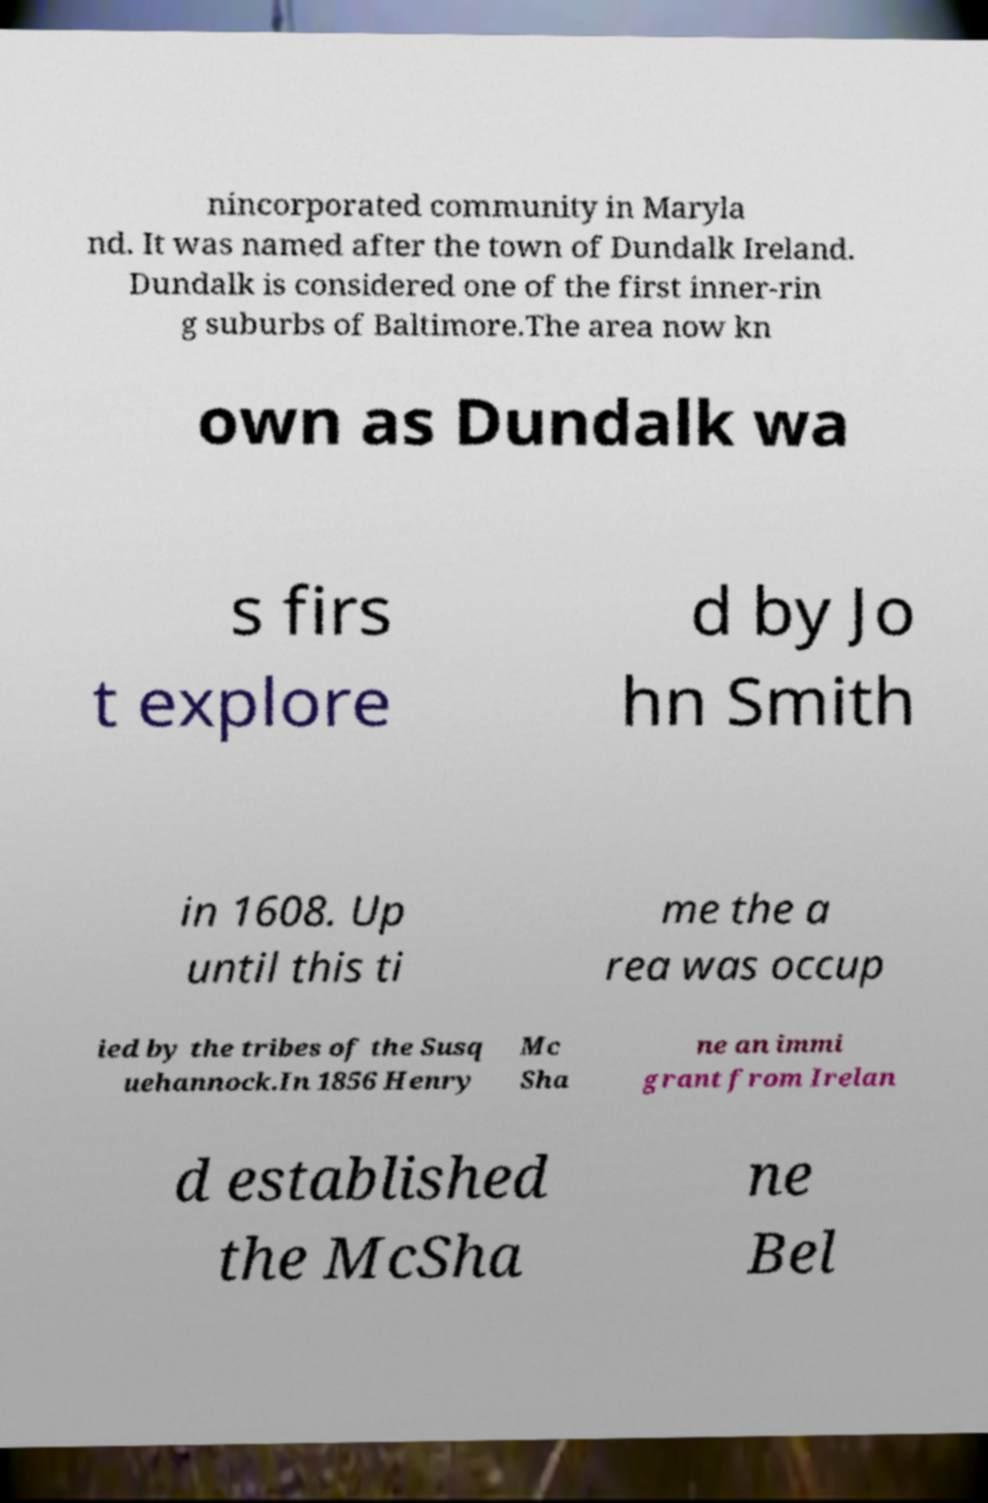Please read and relay the text visible in this image. What does it say? nincorporated community in Maryla nd. It was named after the town of Dundalk Ireland. Dundalk is considered one of the first inner-rin g suburbs of Baltimore.The area now kn own as Dundalk wa s firs t explore d by Jo hn Smith in 1608. Up until this ti me the a rea was occup ied by the tribes of the Susq uehannock.In 1856 Henry Mc Sha ne an immi grant from Irelan d established the McSha ne Bel 